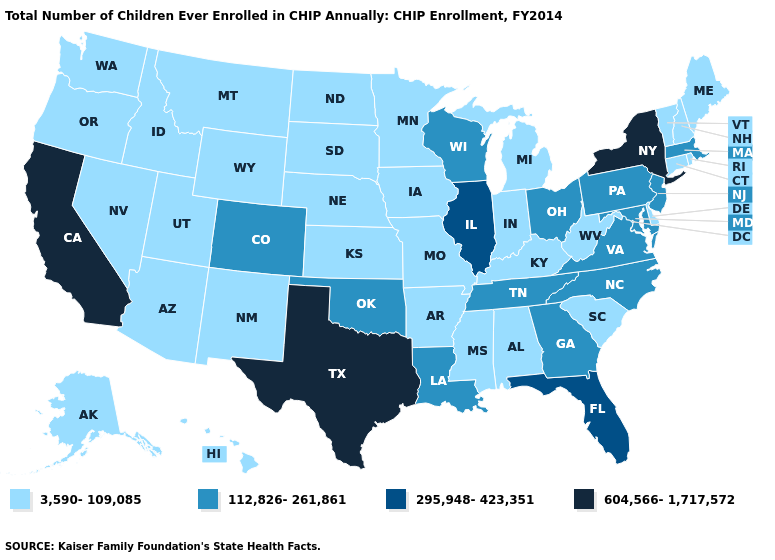Name the states that have a value in the range 3,590-109,085?
Answer briefly. Alabama, Alaska, Arizona, Arkansas, Connecticut, Delaware, Hawaii, Idaho, Indiana, Iowa, Kansas, Kentucky, Maine, Michigan, Minnesota, Mississippi, Missouri, Montana, Nebraska, Nevada, New Hampshire, New Mexico, North Dakota, Oregon, Rhode Island, South Carolina, South Dakota, Utah, Vermont, Washington, West Virginia, Wyoming. What is the value of New Hampshire?
Short answer required. 3,590-109,085. Name the states that have a value in the range 112,826-261,861?
Short answer required. Colorado, Georgia, Louisiana, Maryland, Massachusetts, New Jersey, North Carolina, Ohio, Oklahoma, Pennsylvania, Tennessee, Virginia, Wisconsin. How many symbols are there in the legend?
Short answer required. 4. What is the highest value in the USA?
Quick response, please. 604,566-1,717,572. Name the states that have a value in the range 295,948-423,351?
Quick response, please. Florida, Illinois. What is the value of Oregon?
Short answer required. 3,590-109,085. How many symbols are there in the legend?
Quick response, please. 4. Name the states that have a value in the range 3,590-109,085?
Quick response, please. Alabama, Alaska, Arizona, Arkansas, Connecticut, Delaware, Hawaii, Idaho, Indiana, Iowa, Kansas, Kentucky, Maine, Michigan, Minnesota, Mississippi, Missouri, Montana, Nebraska, Nevada, New Hampshire, New Mexico, North Dakota, Oregon, Rhode Island, South Carolina, South Dakota, Utah, Vermont, Washington, West Virginia, Wyoming. Among the states that border Rhode Island , which have the highest value?
Concise answer only. Massachusetts. Does Maryland have the highest value in the USA?
Be succinct. No. What is the lowest value in the West?
Keep it brief. 3,590-109,085. Does the map have missing data?
Write a very short answer. No. How many symbols are there in the legend?
Write a very short answer. 4. Does California have the highest value in the USA?
Short answer required. Yes. 